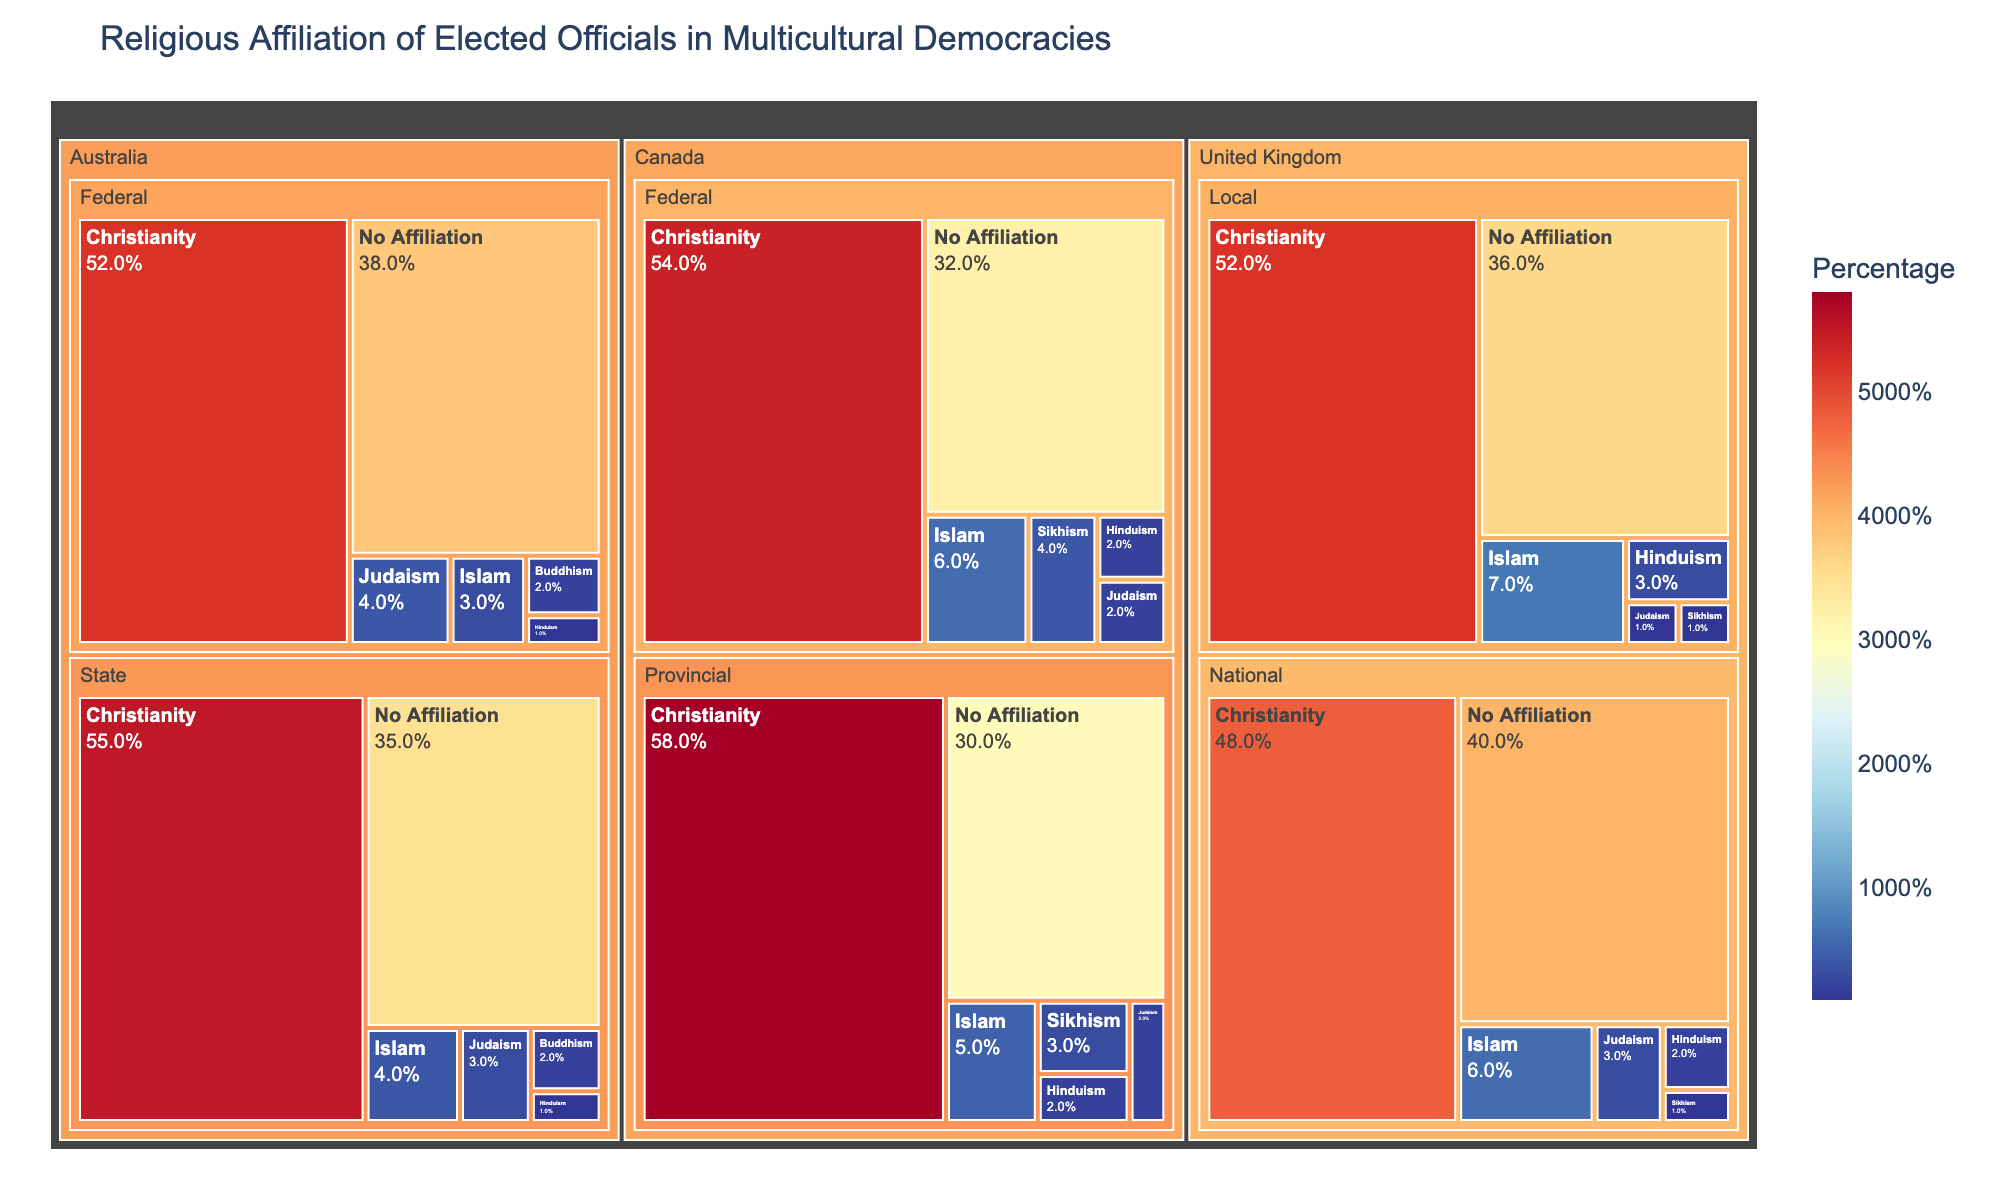What is the title of the treemap? The title is usually at the top of the figure, and it provides an overview of what the visualization represents.
Answer: Religious Affiliation of Elected Officials in Multicultural Democracies Which country at the federal level has the highest percentage of elected officials with no religious affiliation? Visualize the federal level section for each country and identify the segment with the highest percentage labeled "No Affiliation."
Answer: Australia What is the combined percentage of Christian elected officials at both the federal and provincial levels in Canada? Sum up the percentage of Christian elected officials at the federal and provincial levels in Canada: Federal (54%) + Provincial (58%) = 112%.
Answer: 112% Which country and government level show the highest representation of officials identifying with Islam? Locate the segments representing the percentage of Islamic officials across all countries and levels of government, and identify the maximum. The highest segment has the largest area proportion.
Answer: United Kingdom, Local Compare the percentage of elected officials affiliated with Christianity between the national level in the United Kingdom and the federal level in Australia. Which is higher and by how much? The percentage of Christian officials in the UK (National) is 48%, and in Australia (Federal), it is 52%. To compare: 52% - 48% = 4%.
Answer: Australia, by 4% What is the smallest religious group among elected officials at the state level in Australia? At the state level, locate the segment with the smallest percentage. Compare percentages for all listed religions.
Answer: Hinduism In which country and government level do elected officials with no religious affiliation make up exactly 40%? Look for the segment with 40% labeled "No Affiliation" and identify the associated country and government level.
Answer: United Kingdom, National Calculate the average percentage of elected officials with Judaism affiliation across all government levels in Australia. Add the percentages of officials with Judaism affiliation across all levels in Australia and divide by the number of levels: (Federal 4% + State 3%)/2 = 3.5%.
Answer: 3.5% How do the percentages of Sikhism in Canadian federal and provincial governments compare? Compare the segments labeled Sikhism for both federal and provincial levels in Canada: Federal (4%) vs. Provincial (3%).
Answer: Federal is higher by 1% Which government level in Canada shows the highest percentage of elected officials with a non-Christian religious affiliation? Summarize percentages of all non-Christian affiliations at each government level in Canada and compare. Provincial (2% Judaism + 5% Islam + 2% Hinduism + 3% Sikhism = 12%), Federal (2% Judaism + 6% Islam + 2% Hinduism + 4% Sikhism = 14%).
Answer: Federal 